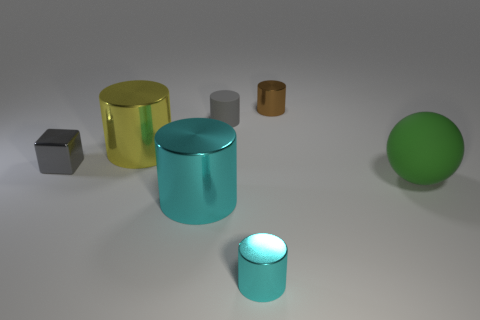What does the composition of the objects and their arrangement tell us? The objects are laid out in a way that appears intentional, with ample space between them, suggesting a showcase or display. It could be an artistic arrangement or perhaps a demonstration of shapes and colors in a design context. 